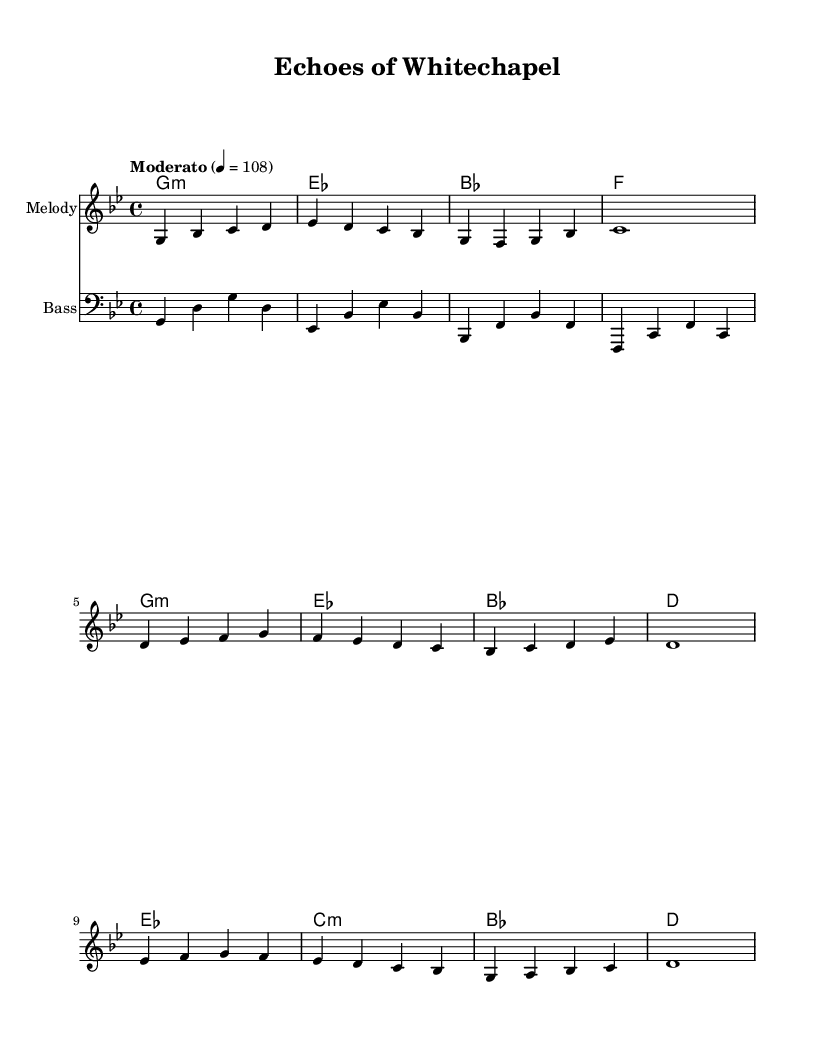What is the key signature of this music? The key signature is G minor, which includes two flats (B flat and E flat). This is indicated at the beginning of the sheet music.
Answer: G minor What is the time signature? The time signature is 4/4, meaning there are four beats in each measure and a quarter note receives one beat. This is also shown at the beginning of the music.
Answer: 4/4 What is the tempo marking? The tempo marking is Moderato, indicating a moderate pace. It specifies a tempo of 108 beats per minute, which is indicated in the score.
Answer: Moderato How many sections are in the piece? The piece contains three sections: Verse, Chorus, and Bridge. Each section is labeled in the melody part of the music, providing a clear structure.
Answer: Three What chord is used in the first measure? The chord used in the first measure is G minor. This is seen in the harmonies section where the first chord matches with the melody.
Answer: G minor Which chord follows the Chorus? The chord that follows the Chorus is D major. This is indicated in the harmonies after the melody's Chorus section. It can be deduced from the structure of the chord progression.
Answer: D major What is the last note of the melody? The last note of the melody is C, which is indicated as a whole note in the last measure of the melody part.
Answer: C 